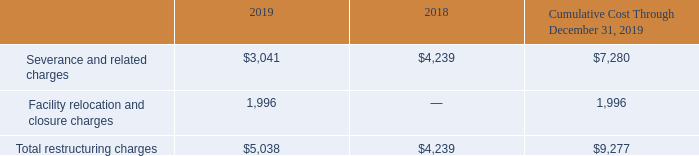ADVANCED ENERGY INDUSTRIES, INC. NOTES TO CONSOLIDATED FINANCIAL STATEMENTS – (continued) (in thousands, except per share amounts)
The table below summarizes the restructuring charges for the years ended:
What were the severance and related charges in 2019?
Answer scale should be: thousand. $3,041. What were the Facility relocation and closure charges in 2019?
Answer scale should be: thousand. 1,996. What was the total restructuring charges in 2018?
Answer scale should be: thousand. $4,239. What was the change in Severance and related charges between 2018 and 2019?
Answer scale should be: thousand. 3,041-4,239
Answer: -1198. What percentage of total restructuring charges in 2019 consisted of Facility relocation and closure charges?
Answer scale should be: percent. 1,996/5,038
Answer: 39.62. What was the percentage change in total restructuring charges between 2018 and 2019?
Answer scale should be: percent. ($5,038-$4,239)/$4,239
Answer: 18.85. 